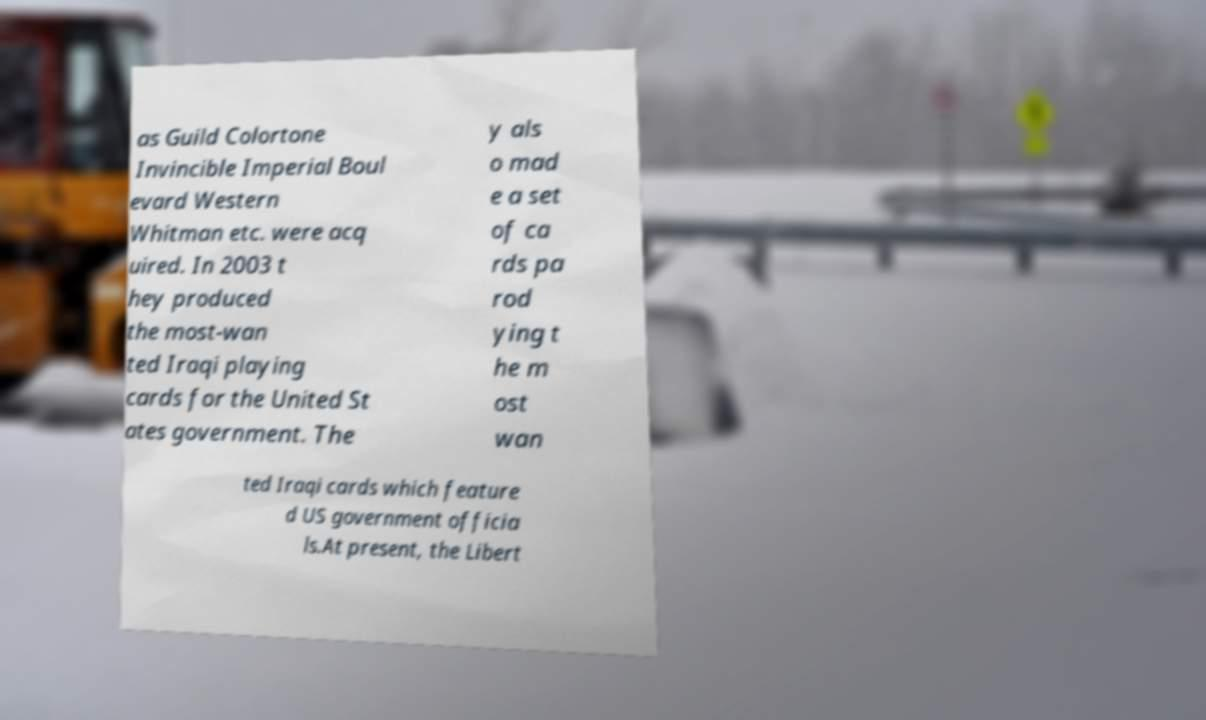What messages or text are displayed in this image? I need them in a readable, typed format. as Guild Colortone Invincible Imperial Boul evard Western Whitman etc. were acq uired. In 2003 t hey produced the most-wan ted Iraqi playing cards for the United St ates government. The y als o mad e a set of ca rds pa rod ying t he m ost wan ted Iraqi cards which feature d US government officia ls.At present, the Libert 